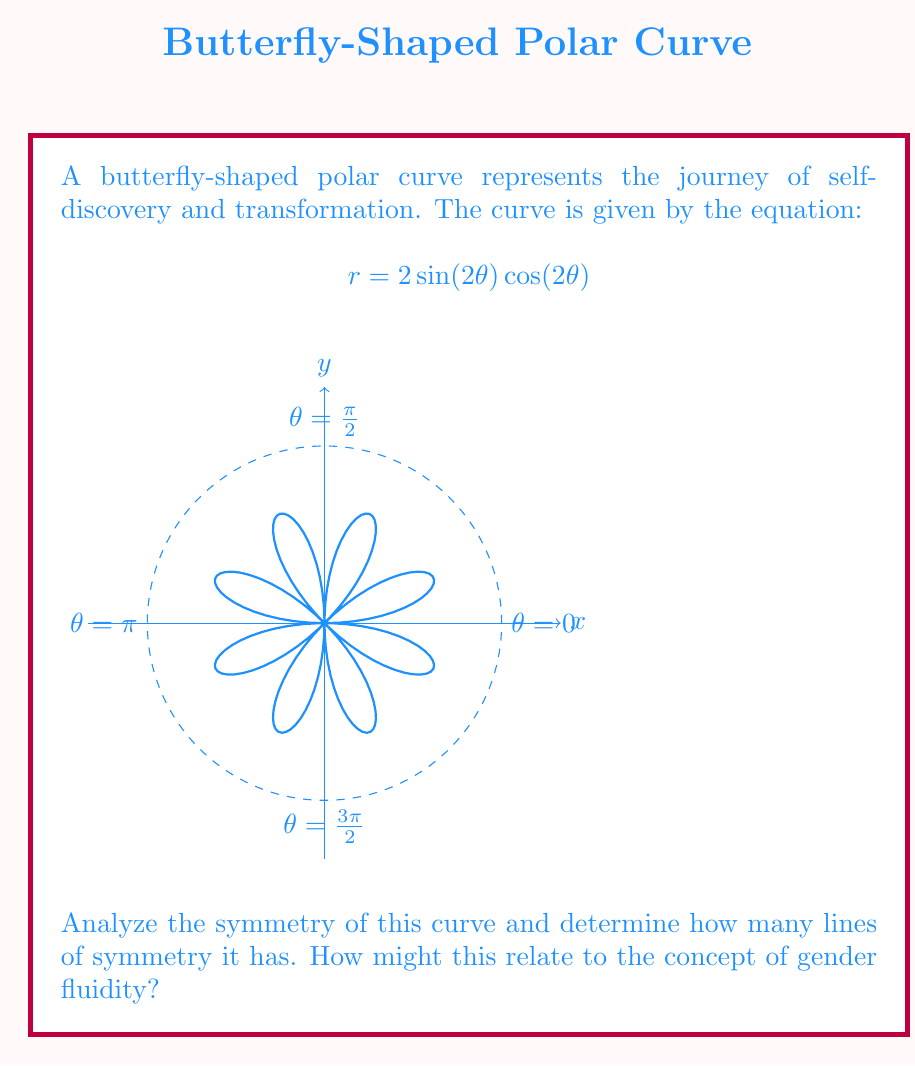Provide a solution to this math problem. To analyze the symmetry of this butterfly-shaped polar curve, let's follow these steps:

1) First, let's consider the equation: $r = 2\sin(2\theta) \cos(2\theta)$

2) This can be rewritten using the double angle formula for sine:
   $r = 2 \cdot \frac{1}{2}\sin(4\theta) = \sin(4\theta)$

3) The period of $\sin(4\theta)$ is $\frac{\pi}{2}$, which means the curve repeats every $\frac{\pi}{2}$ radians.

4) Now, let's consider the symmetry:
   - The curve is symmetric about the x-axis ($\theta = 0$ and $\theta = \pi$)
   - It's also symmetric about the y-axis ($\theta = \frac{\pi}{2}$ and $\theta = \frac{3\pi}{2}$)
   - Additionally, it's symmetric about the lines $y = x$ and $y = -x$

5) Therefore, the curve has 4 lines of symmetry.

6) Relating to gender fluidity:
   - The multiple lines of symmetry can represent the various ways gender identity can be expressed.
   - The continuous, flowing nature of the curve might symbolize the fluidity and non-binary nature of gender for some individuals.
   - The transformation from one "wing" to another could represent the journey of self-discovery and change in gender expression.

This mathematical representation encourages understanding and acceptance of diverse gender identities, aligning with the progressive parenting approach of supporting a teenager's exploration of gender identity.
Answer: 4 lines of symmetry 